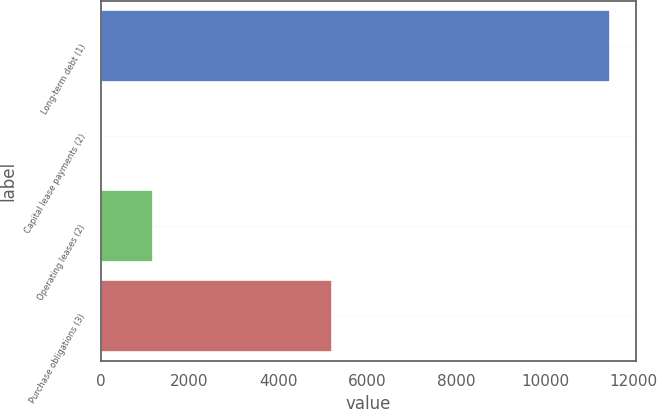Convert chart. <chart><loc_0><loc_0><loc_500><loc_500><bar_chart><fcel>Long-term debt (1)<fcel>Capital lease payments (2)<fcel>Operating leases (2)<fcel>Purchase obligations (3)<nl><fcel>11466<fcel>38<fcel>1180.8<fcel>5199<nl></chart> 